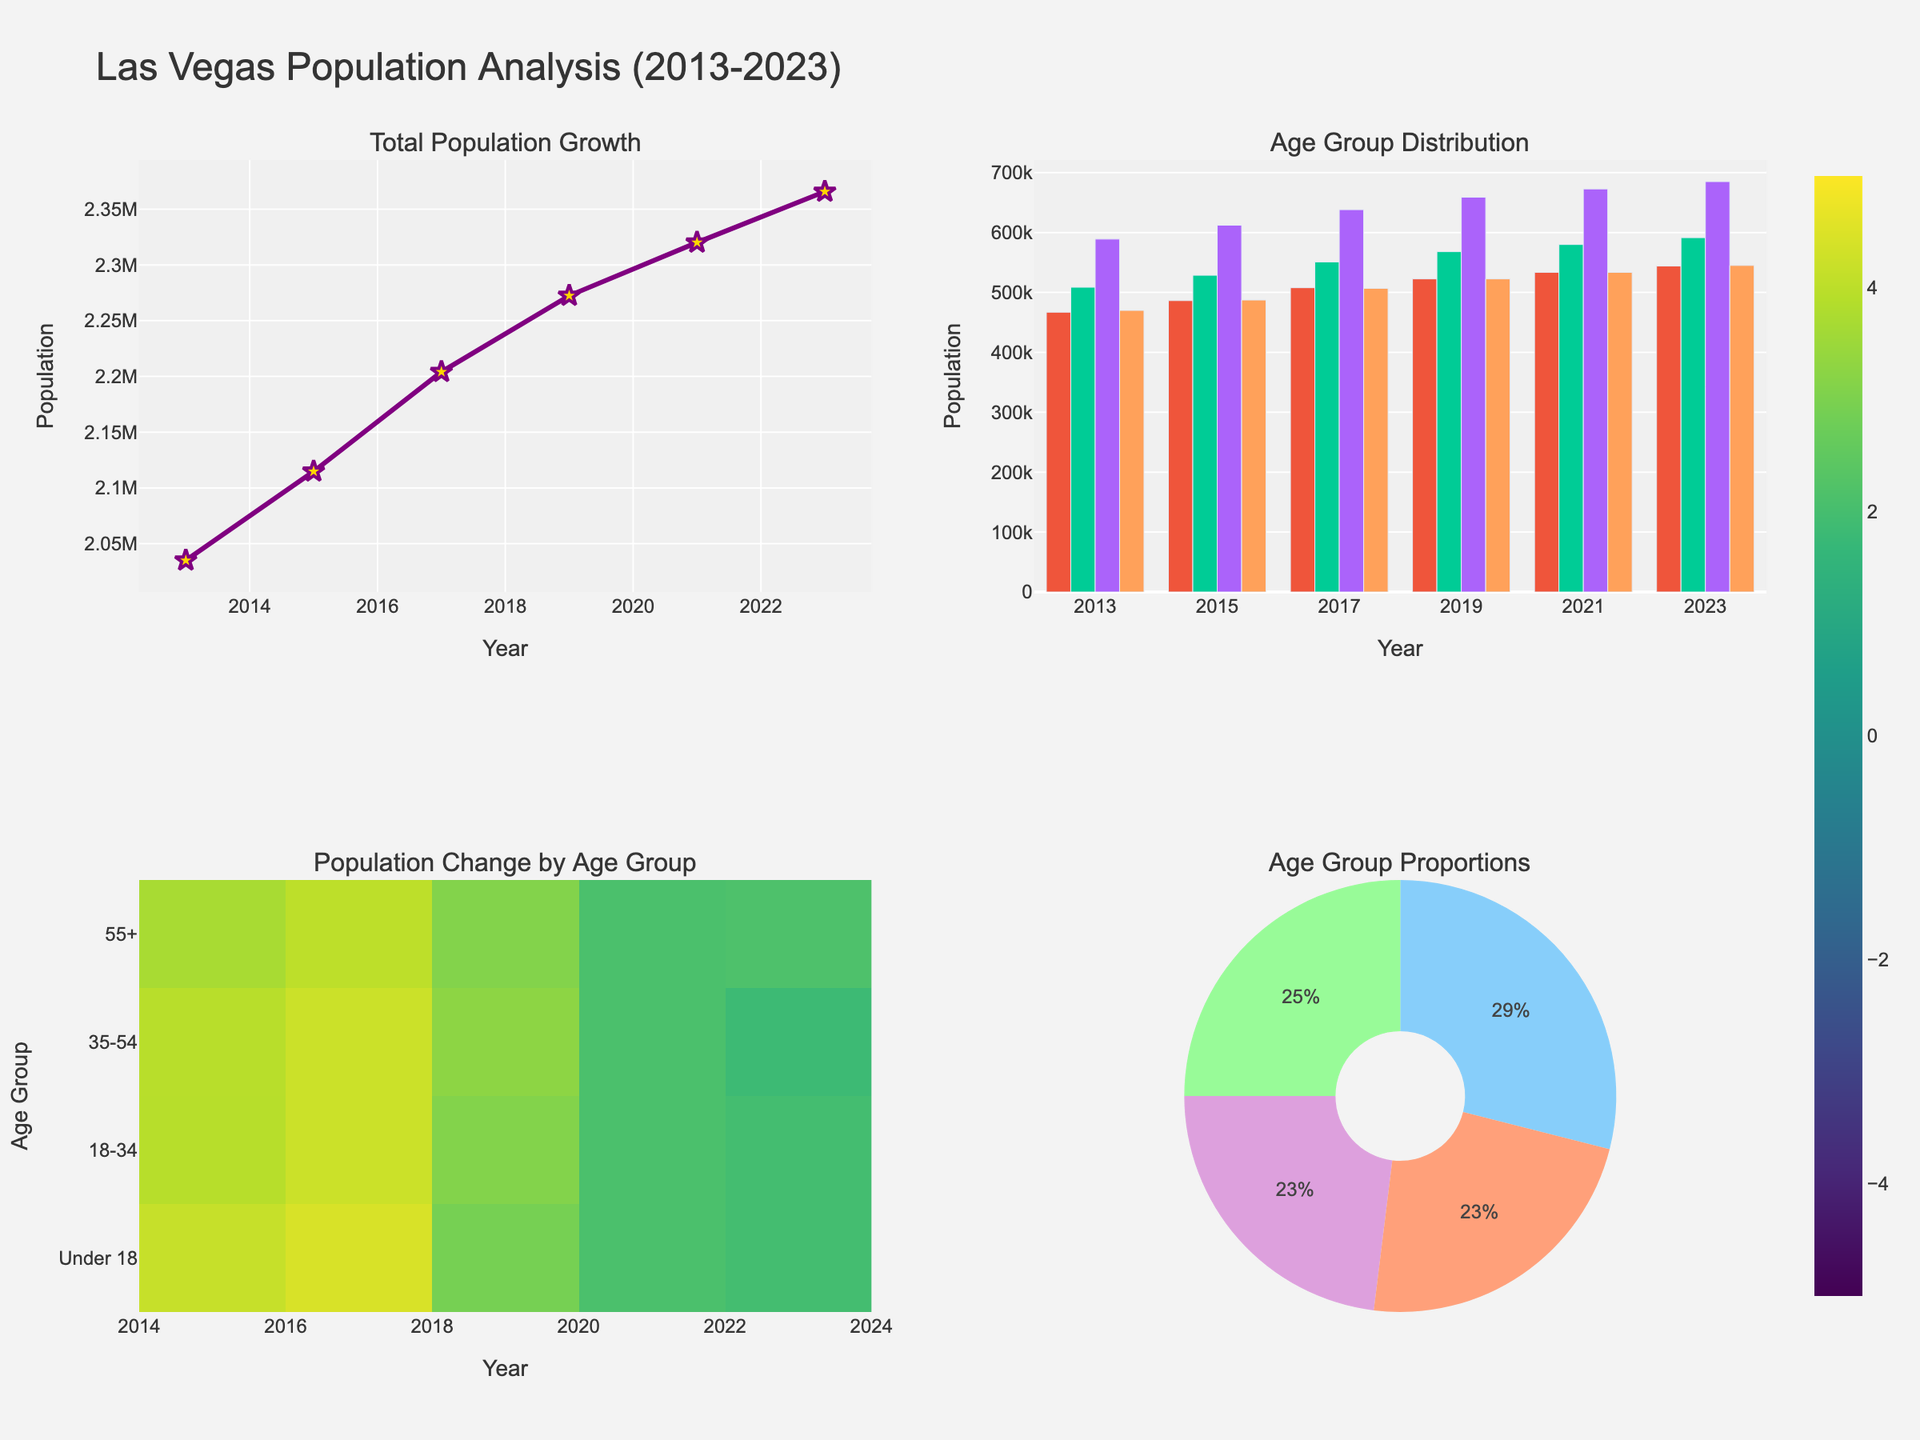What is the title of the figure? The title of the figure is written at the top of the plot and summarizes what the figure is about.
Answer: Las Vegas Population Analysis (2013-2023) How many subplots are there in the figure? By visually counting the different chart types displayed in the figure, you can determine the number of subplots.
Answer: 4 Which age group had the largest population increase from 2013 to 2023? Compare the population values for each age group in 2013 and 2023 to find the group with the largest absolute increase.
Answer: 35-54 What trend can be seen in the total population of Las Vegas from 2013 to 2023? Look at the line chart (subplots row 1, col 1) to observe the overall movement and direction of the total population values over the years.
Answer: Increasing Which age group showed the most consistent population growth over the years? Examine the slopes and consistency of the bars in the stacked bar chart (subplots row 1, col 2) for each age group across the years.
Answer: Under 18 What year experienced the highest percentage change for the “55+” age group? Check the heatmap (subplots row 2, col 1) for the highest value (in percent) corresponding to “55+” across the years.
Answer: 2015 Compare the proportions of age groups in 2023. Which group constitutes the largest share? Refer to the pie chart (subplots row 2, col 2). The size of each pie slice represents the share of each age group in 2023.
Answer: 35-54 What is the general trend observed in the population of the “18-34” age group from 2013 to 2023? Observe the values corresponding to the “18-34” age group in either the stacked bar chart or the line chart to determine the overall trend.
Answer: Increasing Which age group had the smallest population in 2013? By looking at the bar chart (subplots row 1, col 2) for the year 2013, identify the lowest bar which represents that age group.
Answer: 55+ 